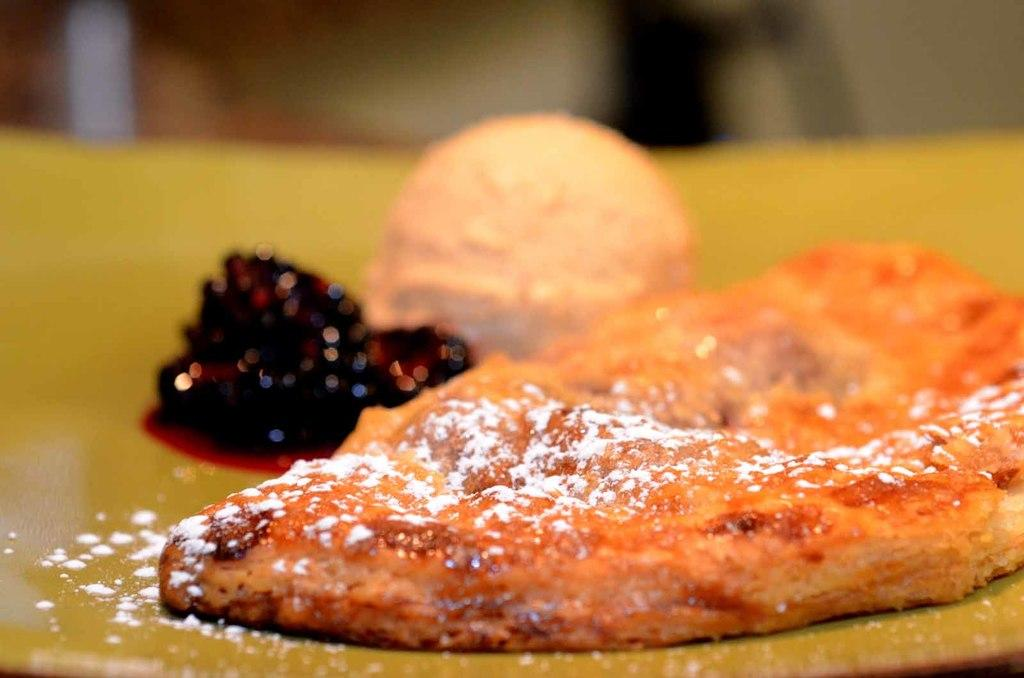What is present on the plate in the image? There are food items present on a plate in the image. How many friends are sitting on the seat in the image? There is no mention of friends or a seat in the image; it only features food items on a plate. 